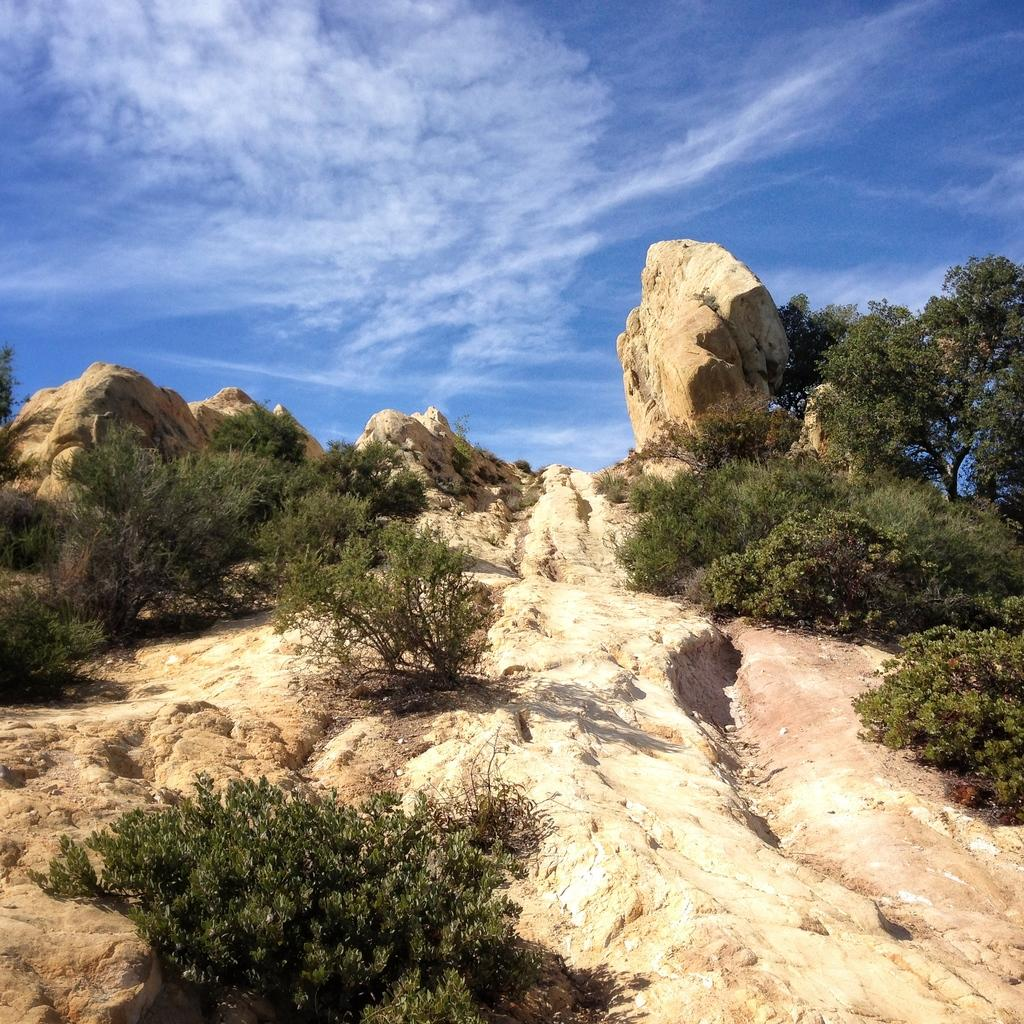What type of geological formation is in the image? There is a stone mountain in the image. What is located at the base of the mountain? There is a plant at the bottom of the mountain. What type of vegetation is on the right side of the image? There are trees on the right side of the image. What is visible at the top of the image? The sky is visible at the top of the image. What can be seen in the sky? Clouds are present in the sky. What type of cough medicine is visible on the mountain in the image? There is no cough medicine present in the image; it features a stone mountain, a plant, trees, and a sky with clouds. 